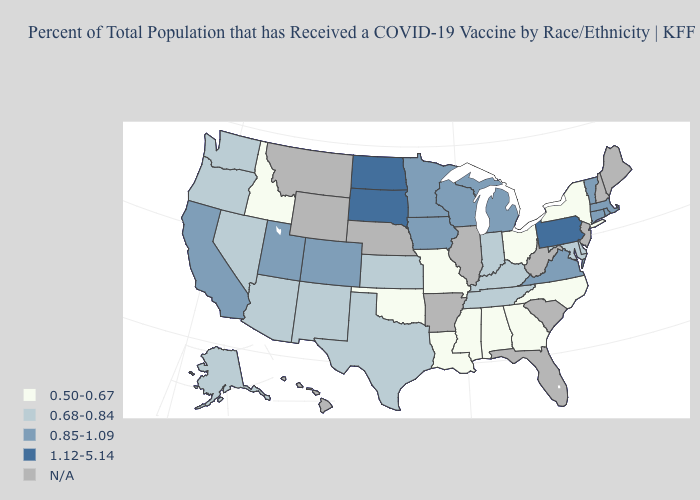What is the lowest value in the West?
Answer briefly. 0.50-0.67. What is the value of New York?
Be succinct. 0.50-0.67. Name the states that have a value in the range 0.50-0.67?
Give a very brief answer. Alabama, Georgia, Idaho, Louisiana, Mississippi, Missouri, New York, North Carolina, Ohio, Oklahoma. What is the value of Nevada?
Keep it brief. 0.68-0.84. Name the states that have a value in the range 1.12-5.14?
Write a very short answer. North Dakota, Pennsylvania, South Dakota. Is the legend a continuous bar?
Short answer required. No. What is the value of Tennessee?
Keep it brief. 0.68-0.84. Among the states that border Georgia , which have the lowest value?
Quick response, please. Alabama, North Carolina. Among the states that border Arizona , does Nevada have the highest value?
Write a very short answer. No. Name the states that have a value in the range 0.50-0.67?
Keep it brief. Alabama, Georgia, Idaho, Louisiana, Mississippi, Missouri, New York, North Carolina, Ohio, Oklahoma. Name the states that have a value in the range 0.68-0.84?
Short answer required. Alaska, Arizona, Delaware, Indiana, Kansas, Kentucky, Maryland, Nevada, New Mexico, Oregon, Tennessee, Texas, Washington. Which states have the lowest value in the USA?
Answer briefly. Alabama, Georgia, Idaho, Louisiana, Mississippi, Missouri, New York, North Carolina, Ohio, Oklahoma. Does the first symbol in the legend represent the smallest category?
Keep it brief. Yes. Does the map have missing data?
Give a very brief answer. Yes. 